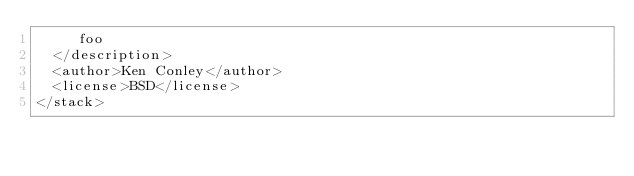<code> <loc_0><loc_0><loc_500><loc_500><_XML_>     foo
  </description>
  <author>Ken Conley</author>
  <license>BSD</license>
</stack>
</code> 